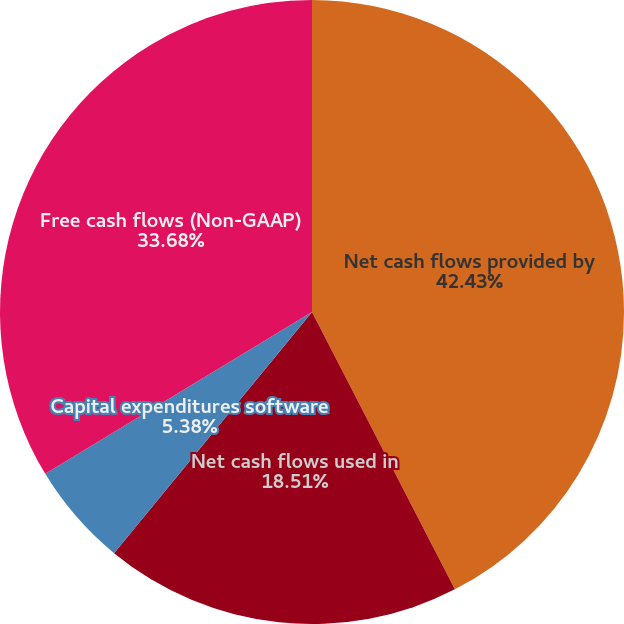Convert chart to OTSL. <chart><loc_0><loc_0><loc_500><loc_500><pie_chart><fcel>Net cash flows provided by<fcel>Net cash flows used in<fcel>Capital expenditures software<fcel>Free cash flows (Non-GAAP)<nl><fcel>42.43%<fcel>18.51%<fcel>5.38%<fcel>33.68%<nl></chart> 